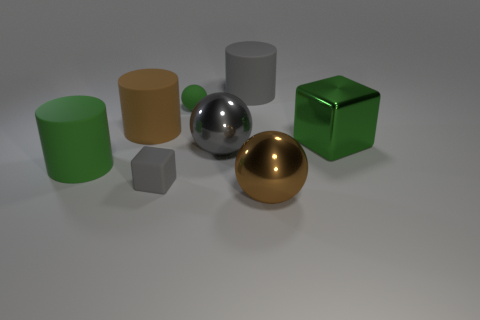Add 1 large blocks. How many objects exist? 9 Subtract all spheres. How many objects are left? 5 Subtract all green objects. Subtract all gray objects. How many objects are left? 2 Add 1 large metallic objects. How many large metallic objects are left? 4 Add 5 small blue metallic cubes. How many small blue metallic cubes exist? 5 Subtract 0 yellow spheres. How many objects are left? 8 